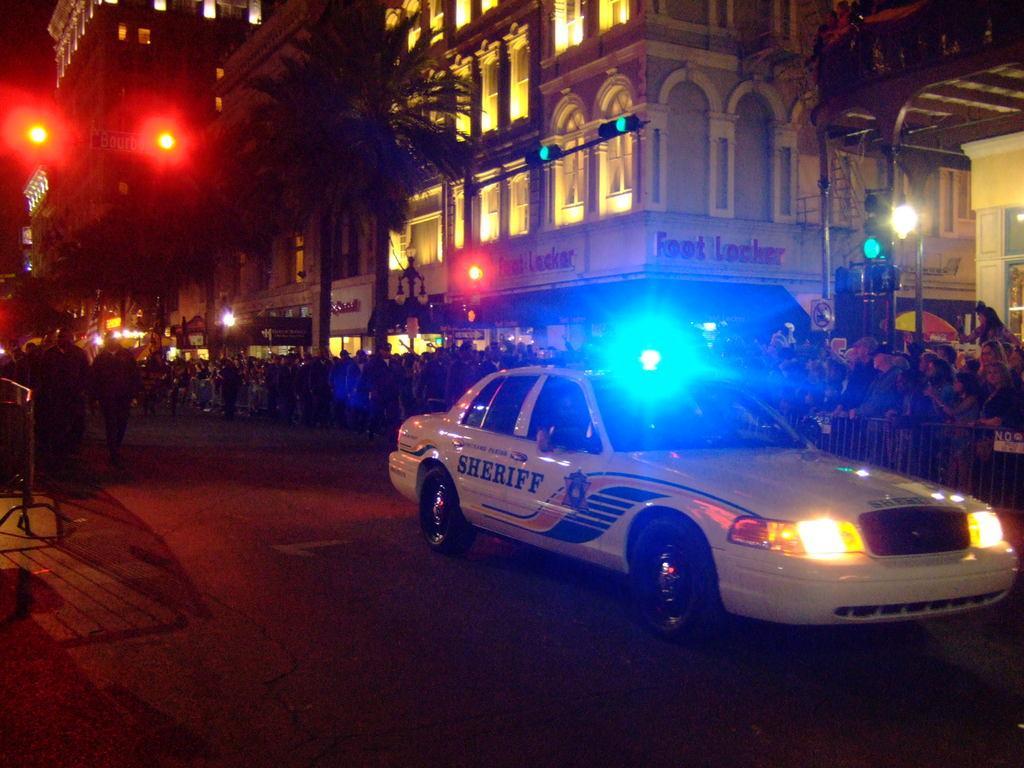Please provide a concise description of this image. In this picture we can see a car on the road. Behind the car, there are groups of people, barricades, trees and buildings. There are poles with the traffic lights. 